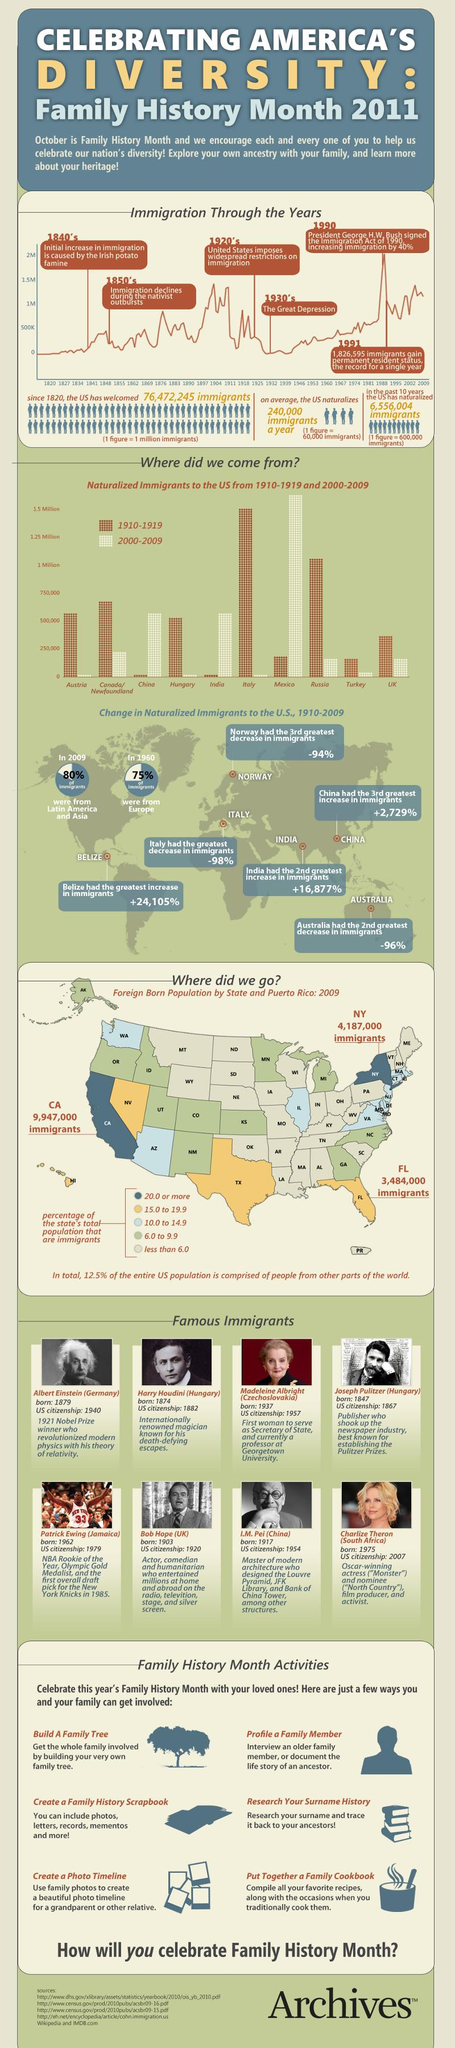Give some essential details in this illustration. In 1990, there was a 40% increase in immigration. According to the list of famous immigrants, only two prominent women are featured. The naturalized immigrants in the United States belong to 10 different countries. I observe that three states are highlighted in yellow. In 1991, the highest number of immigrants gained permanent residency status. 